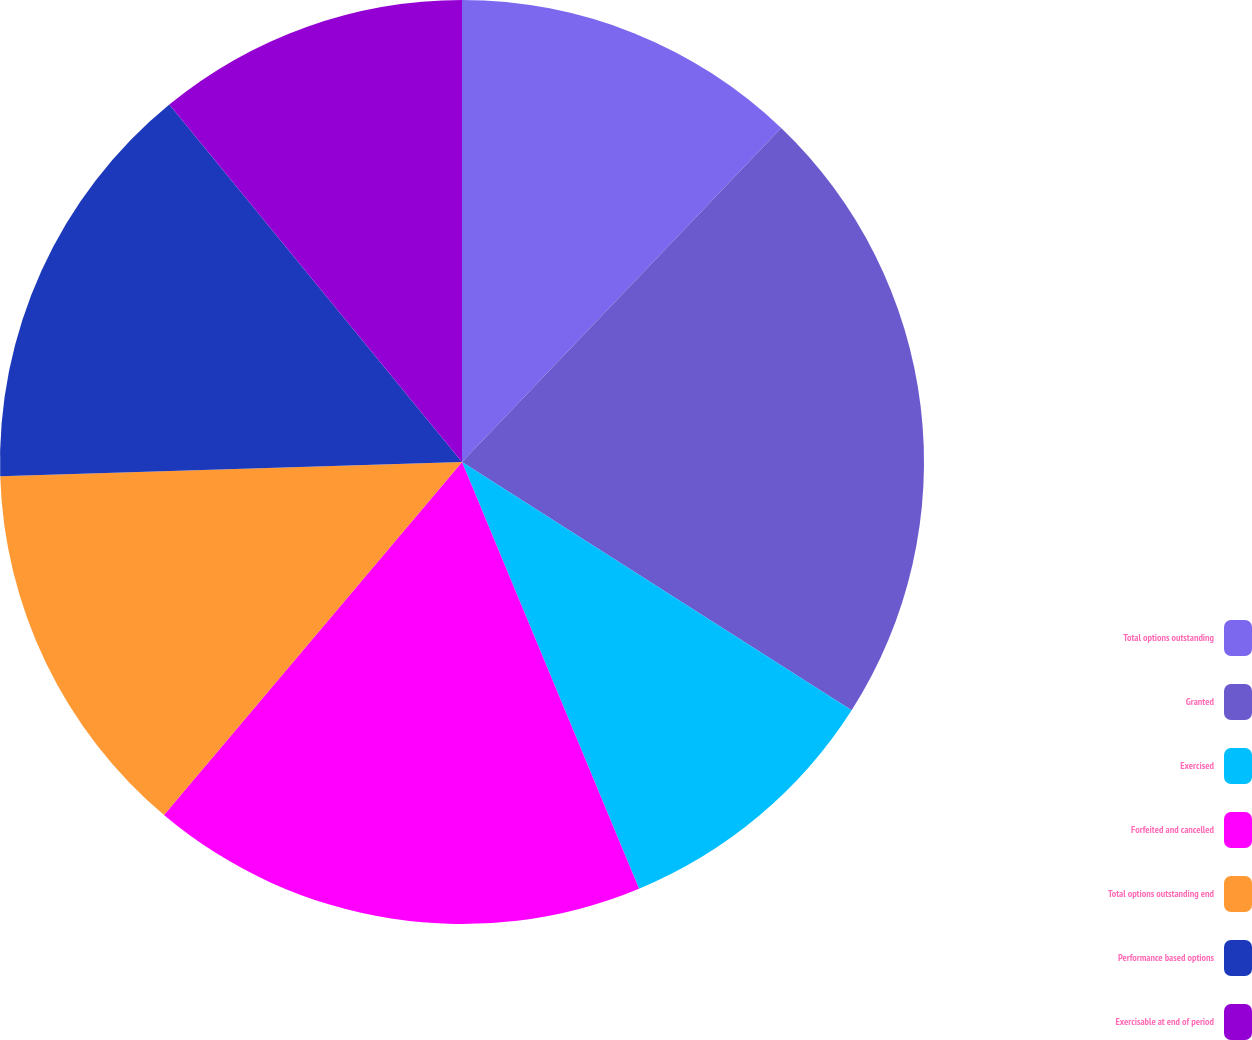<chart> <loc_0><loc_0><loc_500><loc_500><pie_chart><fcel>Total options outstanding<fcel>Granted<fcel>Exercised<fcel>Forfeited and cancelled<fcel>Total options outstanding end<fcel>Performance based options<fcel>Exercisable at end of period<nl><fcel>12.14%<fcel>21.89%<fcel>9.71%<fcel>17.42%<fcel>13.35%<fcel>14.57%<fcel>10.92%<nl></chart> 